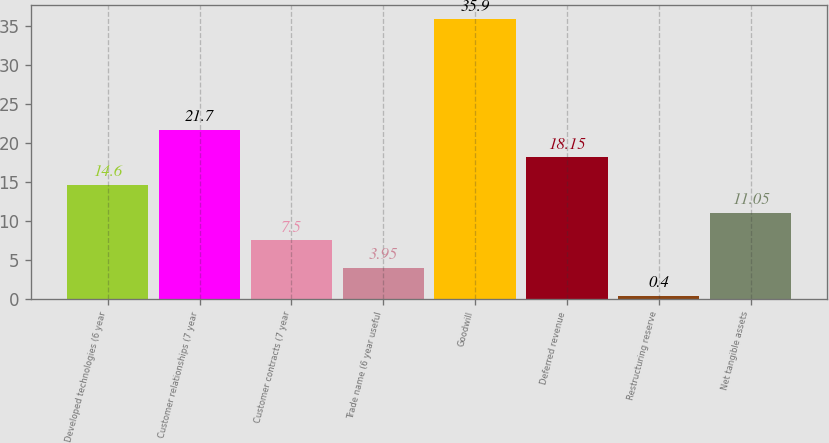Convert chart. <chart><loc_0><loc_0><loc_500><loc_500><bar_chart><fcel>Developed technologies (6 year<fcel>Customer relationships (7 year<fcel>Customer contracts (7 year<fcel>Trade name (6 year useful<fcel>Goodwill<fcel>Deferred revenue<fcel>Restructuring reserve<fcel>Net tangible assets<nl><fcel>14.6<fcel>21.7<fcel>7.5<fcel>3.95<fcel>35.9<fcel>18.15<fcel>0.4<fcel>11.05<nl></chart> 